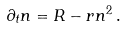Convert formula to latex. <formula><loc_0><loc_0><loc_500><loc_500>\partial _ { t } n = R - r n ^ { 2 } \, .</formula> 